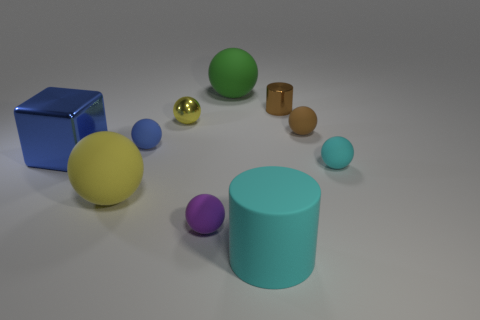Subtract 5 spheres. How many spheres are left? 2 Subtract all tiny matte balls. Subtract all small brown spheres. How many objects are left? 5 Add 6 small brown shiny objects. How many small brown shiny objects are left? 7 Add 7 green blocks. How many green blocks exist? 7 Subtract all green balls. How many balls are left? 6 Subtract all blue spheres. How many spheres are left? 6 Subtract 0 yellow blocks. How many objects are left? 10 Subtract all cylinders. How many objects are left? 8 Subtract all purple balls. Subtract all blue cubes. How many balls are left? 6 Subtract all purple spheres. How many brown cylinders are left? 1 